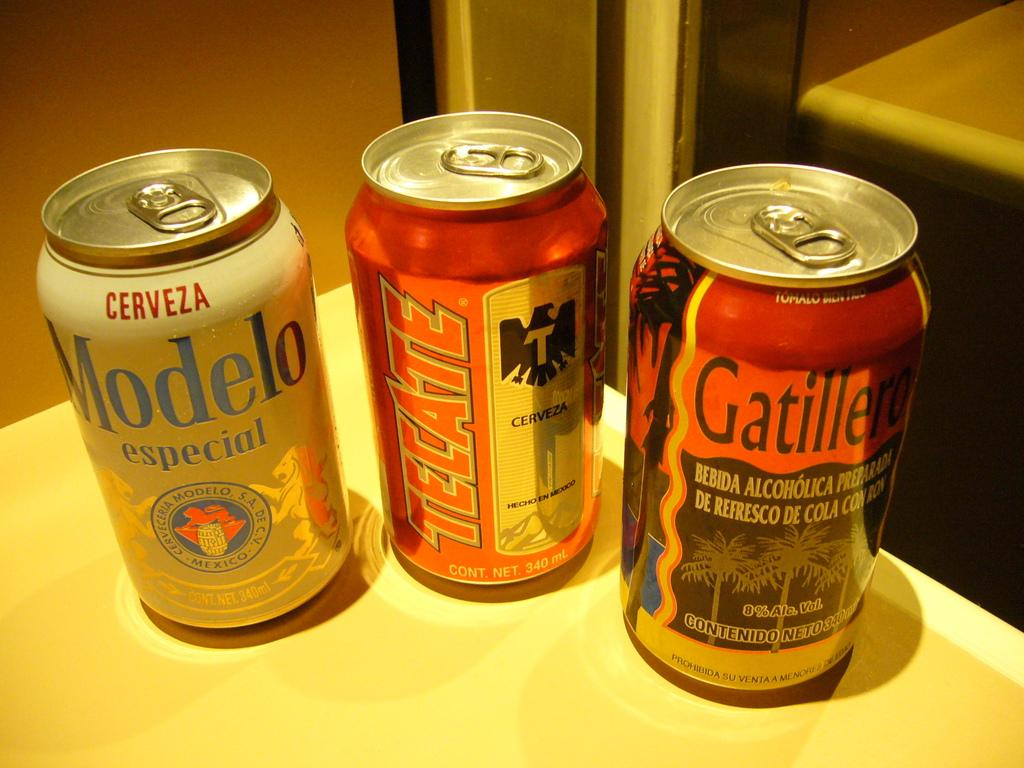How many coke bottles are visible in the image? There are three coke bottles in the image. What colors are the coke bottles? Two of the coke bottles are red, and one is white. Where are the coke bottles located? The coke bottles are placed on a table. What is the color of the table? The table is white. Can you see a hole in any of the coke bottles in the image? No, there are no holes visible in any of the coke bottles in the image. Is there a beetle crawling on the table in the image? No, there is no beetle present in the image. 